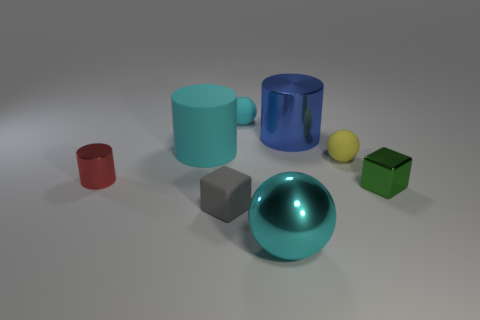Subtract all rubber spheres. How many spheres are left? 1 Add 1 tiny metallic blocks. How many objects exist? 9 Subtract all balls. How many objects are left? 5 Subtract all red cylinders. How many cylinders are left? 2 Subtract 2 cylinders. How many cylinders are left? 1 Subtract all green blocks. Subtract all red balls. How many blocks are left? 1 Subtract all purple cylinders. How many purple cubes are left? 0 Subtract all small purple rubber spheres. Subtract all big metallic balls. How many objects are left? 7 Add 3 small red shiny cylinders. How many small red shiny cylinders are left? 4 Add 2 big shiny objects. How many big shiny objects exist? 4 